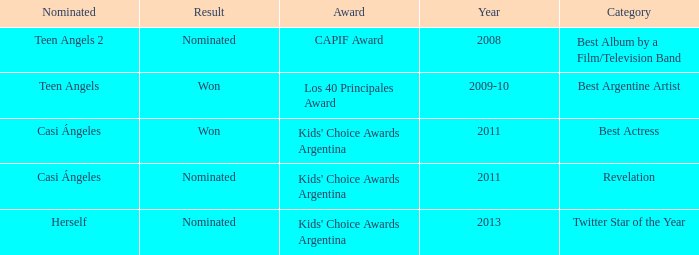In what category was Herself nominated? Twitter Star of the Year. 